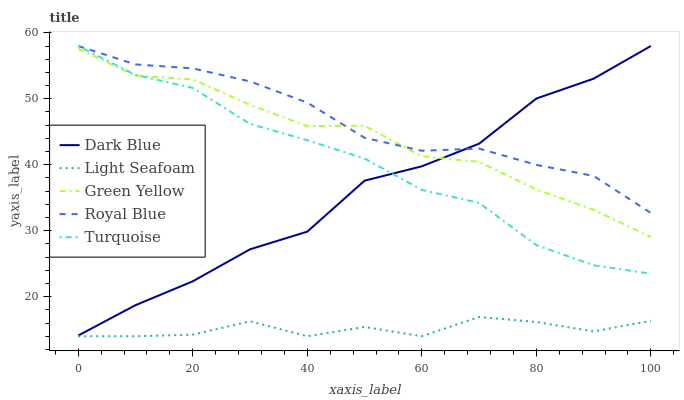Does Light Seafoam have the minimum area under the curve?
Answer yes or no. Yes. Does Royal Blue have the maximum area under the curve?
Answer yes or no. Yes. Does Green Yellow have the minimum area under the curve?
Answer yes or no. No. Does Green Yellow have the maximum area under the curve?
Answer yes or no. No. Is Royal Blue the smoothest?
Answer yes or no. Yes. Is Dark Blue the roughest?
Answer yes or no. Yes. Is Green Yellow the smoothest?
Answer yes or no. No. Is Green Yellow the roughest?
Answer yes or no. No. Does Light Seafoam have the lowest value?
Answer yes or no. Yes. Does Green Yellow have the lowest value?
Answer yes or no. No. Does Royal Blue have the highest value?
Answer yes or no. Yes. Does Green Yellow have the highest value?
Answer yes or no. No. Is Light Seafoam less than Dark Blue?
Answer yes or no. Yes. Is Dark Blue greater than Light Seafoam?
Answer yes or no. Yes. Does Green Yellow intersect Dark Blue?
Answer yes or no. Yes. Is Green Yellow less than Dark Blue?
Answer yes or no. No. Is Green Yellow greater than Dark Blue?
Answer yes or no. No. Does Light Seafoam intersect Dark Blue?
Answer yes or no. No. 